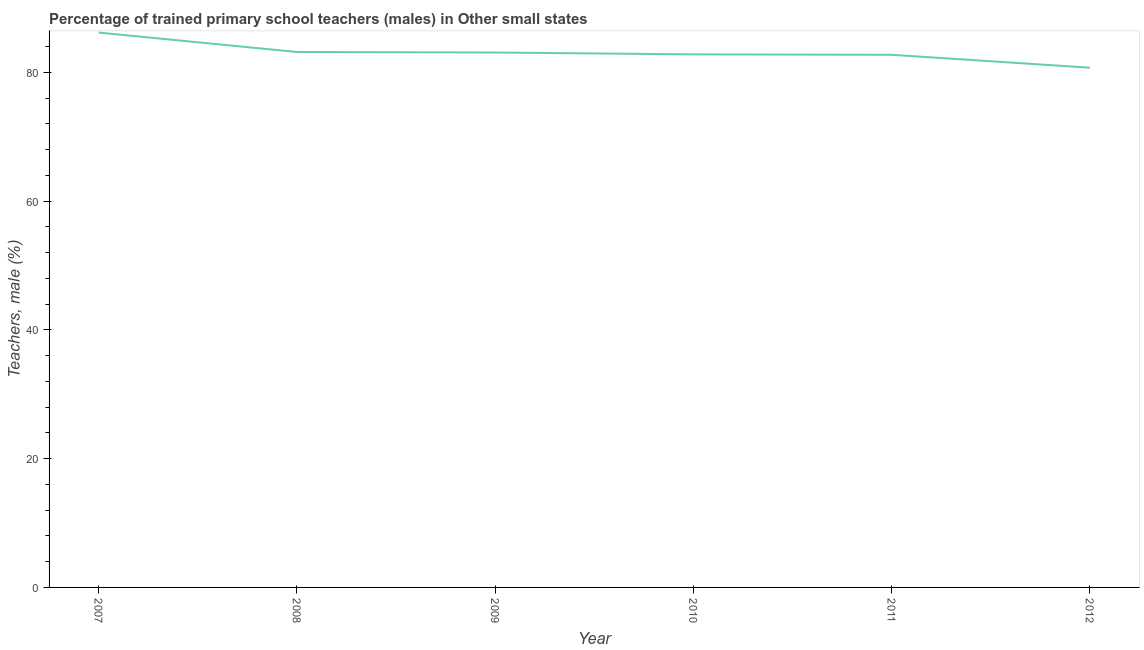What is the percentage of trained male teachers in 2007?
Ensure brevity in your answer.  86.16. Across all years, what is the maximum percentage of trained male teachers?
Provide a short and direct response. 86.16. Across all years, what is the minimum percentage of trained male teachers?
Offer a very short reply. 80.71. In which year was the percentage of trained male teachers minimum?
Offer a terse response. 2012. What is the sum of the percentage of trained male teachers?
Keep it short and to the point. 498.57. What is the difference between the percentage of trained male teachers in 2009 and 2010?
Give a very brief answer. 0.28. What is the average percentage of trained male teachers per year?
Provide a short and direct response. 83.1. What is the median percentage of trained male teachers?
Your response must be concise. 82.92. In how many years, is the percentage of trained male teachers greater than 60 %?
Give a very brief answer. 6. What is the ratio of the percentage of trained male teachers in 2007 to that in 2012?
Ensure brevity in your answer.  1.07. Is the percentage of trained male teachers in 2011 less than that in 2012?
Provide a succinct answer. No. Is the difference between the percentage of trained male teachers in 2007 and 2010 greater than the difference between any two years?
Give a very brief answer. No. What is the difference between the highest and the second highest percentage of trained male teachers?
Keep it short and to the point. 3.01. Is the sum of the percentage of trained male teachers in 2010 and 2011 greater than the maximum percentage of trained male teachers across all years?
Provide a succinct answer. Yes. What is the difference between the highest and the lowest percentage of trained male teachers?
Provide a short and direct response. 5.45. In how many years, is the percentage of trained male teachers greater than the average percentage of trained male teachers taken over all years?
Your answer should be very brief. 2. Does the graph contain any zero values?
Provide a succinct answer. No. Does the graph contain grids?
Make the answer very short. No. What is the title of the graph?
Keep it short and to the point. Percentage of trained primary school teachers (males) in Other small states. What is the label or title of the X-axis?
Give a very brief answer. Year. What is the label or title of the Y-axis?
Your response must be concise. Teachers, male (%). What is the Teachers, male (%) of 2007?
Your answer should be compact. 86.16. What is the Teachers, male (%) of 2008?
Give a very brief answer. 83.15. What is the Teachers, male (%) of 2009?
Your answer should be compact. 83.06. What is the Teachers, male (%) in 2010?
Your response must be concise. 82.78. What is the Teachers, male (%) in 2011?
Give a very brief answer. 82.71. What is the Teachers, male (%) of 2012?
Your response must be concise. 80.71. What is the difference between the Teachers, male (%) in 2007 and 2008?
Make the answer very short. 3.01. What is the difference between the Teachers, male (%) in 2007 and 2009?
Offer a terse response. 3.1. What is the difference between the Teachers, male (%) in 2007 and 2010?
Provide a short and direct response. 3.38. What is the difference between the Teachers, male (%) in 2007 and 2011?
Make the answer very short. 3.45. What is the difference between the Teachers, male (%) in 2007 and 2012?
Offer a very short reply. 5.45. What is the difference between the Teachers, male (%) in 2008 and 2009?
Provide a short and direct response. 0.09. What is the difference between the Teachers, male (%) in 2008 and 2010?
Ensure brevity in your answer.  0.37. What is the difference between the Teachers, male (%) in 2008 and 2011?
Your answer should be compact. 0.44. What is the difference between the Teachers, male (%) in 2008 and 2012?
Provide a short and direct response. 2.44. What is the difference between the Teachers, male (%) in 2009 and 2010?
Make the answer very short. 0.28. What is the difference between the Teachers, male (%) in 2009 and 2011?
Offer a terse response. 0.35. What is the difference between the Teachers, male (%) in 2009 and 2012?
Give a very brief answer. 2.35. What is the difference between the Teachers, male (%) in 2010 and 2011?
Give a very brief answer. 0.07. What is the difference between the Teachers, male (%) in 2010 and 2012?
Keep it short and to the point. 2.07. What is the difference between the Teachers, male (%) in 2011 and 2012?
Your response must be concise. 2. What is the ratio of the Teachers, male (%) in 2007 to that in 2008?
Your answer should be compact. 1.04. What is the ratio of the Teachers, male (%) in 2007 to that in 2009?
Offer a terse response. 1.04. What is the ratio of the Teachers, male (%) in 2007 to that in 2010?
Your answer should be very brief. 1.04. What is the ratio of the Teachers, male (%) in 2007 to that in 2011?
Give a very brief answer. 1.04. What is the ratio of the Teachers, male (%) in 2007 to that in 2012?
Your answer should be very brief. 1.07. What is the ratio of the Teachers, male (%) in 2008 to that in 2009?
Provide a succinct answer. 1. What is the ratio of the Teachers, male (%) in 2008 to that in 2010?
Offer a very short reply. 1. What is the ratio of the Teachers, male (%) in 2008 to that in 2012?
Keep it short and to the point. 1.03. What is the ratio of the Teachers, male (%) in 2009 to that in 2011?
Offer a very short reply. 1. What is the ratio of the Teachers, male (%) in 2009 to that in 2012?
Offer a terse response. 1.03. What is the ratio of the Teachers, male (%) in 2010 to that in 2011?
Offer a terse response. 1. What is the ratio of the Teachers, male (%) in 2010 to that in 2012?
Your answer should be very brief. 1.03. What is the ratio of the Teachers, male (%) in 2011 to that in 2012?
Ensure brevity in your answer.  1.02. 